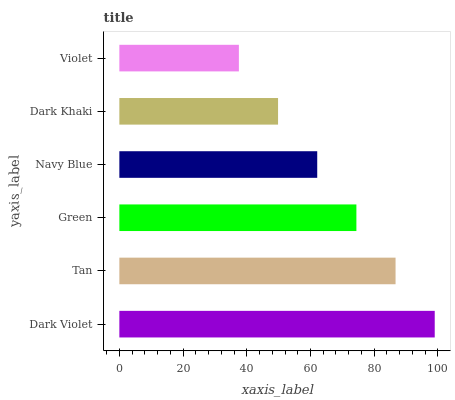Is Violet the minimum?
Answer yes or no. Yes. Is Dark Violet the maximum?
Answer yes or no. Yes. Is Tan the minimum?
Answer yes or no. No. Is Tan the maximum?
Answer yes or no. No. Is Dark Violet greater than Tan?
Answer yes or no. Yes. Is Tan less than Dark Violet?
Answer yes or no. Yes. Is Tan greater than Dark Violet?
Answer yes or no. No. Is Dark Violet less than Tan?
Answer yes or no. No. Is Green the high median?
Answer yes or no. Yes. Is Navy Blue the low median?
Answer yes or no. Yes. Is Dark Violet the high median?
Answer yes or no. No. Is Dark Violet the low median?
Answer yes or no. No. 